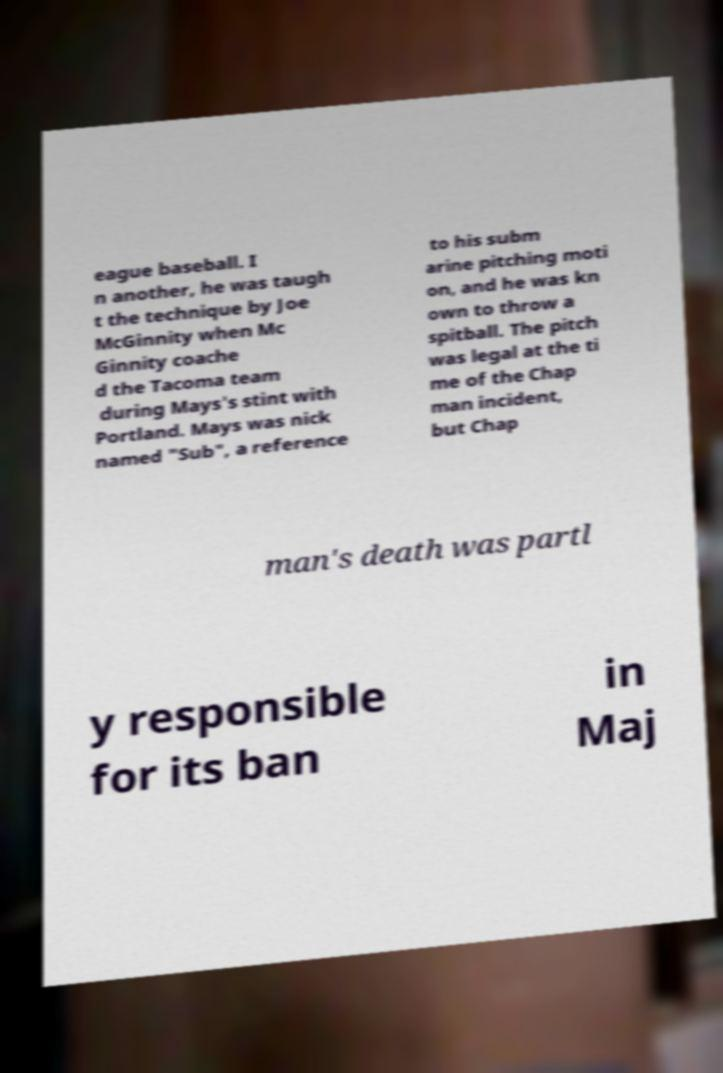Could you assist in decoding the text presented in this image and type it out clearly? eague baseball. I n another, he was taugh t the technique by Joe McGinnity when Mc Ginnity coache d the Tacoma team during Mays's stint with Portland. Mays was nick named "Sub", a reference to his subm arine pitching moti on, and he was kn own to throw a spitball. The pitch was legal at the ti me of the Chap man incident, but Chap man's death was partl y responsible for its ban in Maj 